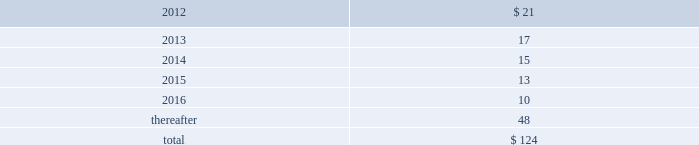The company has also encountered various quality issues on its aircraft carrier construction and overhaul programs and its virginia-class submarine construction program at its newport news location .
These primarily involve matters related to filler metal used in pipe welds identified in 2007 , and issues associated with non-nuclear weld inspection and the installation of weapons handling equipment on certain submarines , and certain purchased material quality issues identified in 2009 .
The company does not believe that resolution of these issues will have a material effect upon its consolidated financial position , results of operations or cash flows .
Environmental matters 2014the estimated cost to complete environmental remediation has been accrued where it is probable that the company will incur such costs in the future to address environmental conditions at currently or formerly owned or leased operating facilities , or at sites where it has been named a potentially responsible party ( 201cprp 201d ) by the environmental protection agency , or similarly designated by another environmental agency , and these costs can be estimated by management .
These accruals do not include any litigation costs related to environmental matters , nor do they include amounts recorded as asset retirement obligations .
To assess the potential impact on the company 2019s consolidated financial statements , management estimates the range of reasonably possible remediation costs that could be incurred by the company , taking into account currently available facts on each site as well as the current state of technology and prior experience in remediating contaminated sites .
These estimates are reviewed periodically and adjusted to reflect changes in facts and technical and legal circumstances .
Management estimates that as of december 31 , 2011 , the probable future costs for environmental remediation is $ 3 million , which is accrued in other current liabilities .
Factors that could result in changes to the company 2019s estimates include : modification of planned remedial actions , increases or decreases in the estimated time required to remediate , changes to the determination of legally responsible parties , discovery of more extensive contamination than anticipated , changes in laws and regulations affecting remediation requirements , and improvements in remediation technology .
Should other prps not pay their allocable share of remediation costs , the company may have to incur costs exceeding those already estimated and accrued .
In addition , there are certain potential remediation sites where the costs of remediation cannot be reasonably estimated .
Although management cannot predict whether new information gained as projects progress will materially affect the estimated liability accrued , management does not believe that future remediation expenditures will have a material effect on the company 2019s consolidated financial position , results of operations or cash flows .
Financial arrangements 2014in the ordinary course of business , hii uses standby letters of credit issued by commercial banks and surety bonds issued by insurance companies principally to support the company 2019s self-insured workers 2019 compensation plans .
At december 31 , 2011 , there were $ 121 million of standby letters of credit issued but undrawn and $ 297 million of surety bonds outstanding related to hii .
U.s .
Government claims 2014from time to time , the u.s .
Government advises the company of claims and penalties concerning certain potential disallowed costs .
When such findings are presented , the company and u.s .
Government representatives engage in discussions to enable hii to evaluate the merits of these claims as well as to assess the amounts being claimed .
The company does not believe that the outcome of any such matters will have a material effect on its consolidated financial position , results of operations or cash flows .
Collective bargaining agreements 2014the company believes that it maintains good relations with its approximately 38000 employees of which approximately 50% ( 50 % ) are covered by a total of 10 collective bargaining agreements .
The company expects to renegotiate renewals of each of its collective bargaining agreements between 2013 and 2015 as they approach expiration .
Collective bargaining agreements generally expire after three to five years and are subject to renegotiation at that time .
It is not expected that the results of these negotiations , either individually or in the aggregate , will have a material effect on the company 2019s consolidated results of operations .
Operating leases 2014rental expense for operating leases was $ 44 million in 2011 , $ 44 million in 2010 , and $ 48 million in 2009 .
These amounts are net of immaterial amounts of sublease rental income .
Minimum rental commitments under long- term non-cancellable operating leases for the next five years and thereafter are : ( $ in millions ) .

What was the average operating leases 2014rental expense for operating leases from 2009 to 2011? 
Computations: (((44 + 44) + 48) / 3)
Answer: 45.33333. The company has also encountered various quality issues on its aircraft carrier construction and overhaul programs and its virginia-class submarine construction program at its newport news location .
These primarily involve matters related to filler metal used in pipe welds identified in 2007 , and issues associated with non-nuclear weld inspection and the installation of weapons handling equipment on certain submarines , and certain purchased material quality issues identified in 2009 .
The company does not believe that resolution of these issues will have a material effect upon its consolidated financial position , results of operations or cash flows .
Environmental matters 2014the estimated cost to complete environmental remediation has been accrued where it is probable that the company will incur such costs in the future to address environmental conditions at currently or formerly owned or leased operating facilities , or at sites where it has been named a potentially responsible party ( 201cprp 201d ) by the environmental protection agency , or similarly designated by another environmental agency , and these costs can be estimated by management .
These accruals do not include any litigation costs related to environmental matters , nor do they include amounts recorded as asset retirement obligations .
To assess the potential impact on the company 2019s consolidated financial statements , management estimates the range of reasonably possible remediation costs that could be incurred by the company , taking into account currently available facts on each site as well as the current state of technology and prior experience in remediating contaminated sites .
These estimates are reviewed periodically and adjusted to reflect changes in facts and technical and legal circumstances .
Management estimates that as of december 31 , 2011 , the probable future costs for environmental remediation is $ 3 million , which is accrued in other current liabilities .
Factors that could result in changes to the company 2019s estimates include : modification of planned remedial actions , increases or decreases in the estimated time required to remediate , changes to the determination of legally responsible parties , discovery of more extensive contamination than anticipated , changes in laws and regulations affecting remediation requirements , and improvements in remediation technology .
Should other prps not pay their allocable share of remediation costs , the company may have to incur costs exceeding those already estimated and accrued .
In addition , there are certain potential remediation sites where the costs of remediation cannot be reasonably estimated .
Although management cannot predict whether new information gained as projects progress will materially affect the estimated liability accrued , management does not believe that future remediation expenditures will have a material effect on the company 2019s consolidated financial position , results of operations or cash flows .
Financial arrangements 2014in the ordinary course of business , hii uses standby letters of credit issued by commercial banks and surety bonds issued by insurance companies principally to support the company 2019s self-insured workers 2019 compensation plans .
At december 31 , 2011 , there were $ 121 million of standby letters of credit issued but undrawn and $ 297 million of surety bonds outstanding related to hii .
U.s .
Government claims 2014from time to time , the u.s .
Government advises the company of claims and penalties concerning certain potential disallowed costs .
When such findings are presented , the company and u.s .
Government representatives engage in discussions to enable hii to evaluate the merits of these claims as well as to assess the amounts being claimed .
The company does not believe that the outcome of any such matters will have a material effect on its consolidated financial position , results of operations or cash flows .
Collective bargaining agreements 2014the company believes that it maintains good relations with its approximately 38000 employees of which approximately 50% ( 50 % ) are covered by a total of 10 collective bargaining agreements .
The company expects to renegotiate renewals of each of its collective bargaining agreements between 2013 and 2015 as they approach expiration .
Collective bargaining agreements generally expire after three to five years and are subject to renegotiation at that time .
It is not expected that the results of these negotiations , either individually or in the aggregate , will have a material effect on the company 2019s consolidated results of operations .
Operating leases 2014rental expense for operating leases was $ 44 million in 2011 , $ 44 million in 2010 , and $ 48 million in 2009 .
These amounts are net of immaterial amounts of sublease rental income .
Minimum rental commitments under long- term non-cancellable operating leases for the next five years and thereafter are : ( $ in millions ) .

What is the percentage change in rent expenses for operating leases in 2010 compare to 2009? 
Computations: ((44 - 48) / 48)
Answer: -0.08333. The company has also encountered various quality issues on its aircraft carrier construction and overhaul programs and its virginia-class submarine construction program at its newport news location .
These primarily involve matters related to filler metal used in pipe welds identified in 2007 , and issues associated with non-nuclear weld inspection and the installation of weapons handling equipment on certain submarines , and certain purchased material quality issues identified in 2009 .
The company does not believe that resolution of these issues will have a material effect upon its consolidated financial position , results of operations or cash flows .
Environmental matters 2014the estimated cost to complete environmental remediation has been accrued where it is probable that the company will incur such costs in the future to address environmental conditions at currently or formerly owned or leased operating facilities , or at sites where it has been named a potentially responsible party ( 201cprp 201d ) by the environmental protection agency , or similarly designated by another environmental agency , and these costs can be estimated by management .
These accruals do not include any litigation costs related to environmental matters , nor do they include amounts recorded as asset retirement obligations .
To assess the potential impact on the company 2019s consolidated financial statements , management estimates the range of reasonably possible remediation costs that could be incurred by the company , taking into account currently available facts on each site as well as the current state of technology and prior experience in remediating contaminated sites .
These estimates are reviewed periodically and adjusted to reflect changes in facts and technical and legal circumstances .
Management estimates that as of december 31 , 2011 , the probable future costs for environmental remediation is $ 3 million , which is accrued in other current liabilities .
Factors that could result in changes to the company 2019s estimates include : modification of planned remedial actions , increases or decreases in the estimated time required to remediate , changes to the determination of legally responsible parties , discovery of more extensive contamination than anticipated , changes in laws and regulations affecting remediation requirements , and improvements in remediation technology .
Should other prps not pay their allocable share of remediation costs , the company may have to incur costs exceeding those already estimated and accrued .
In addition , there are certain potential remediation sites where the costs of remediation cannot be reasonably estimated .
Although management cannot predict whether new information gained as projects progress will materially affect the estimated liability accrued , management does not believe that future remediation expenditures will have a material effect on the company 2019s consolidated financial position , results of operations or cash flows .
Financial arrangements 2014in the ordinary course of business , hii uses standby letters of credit issued by commercial banks and surety bonds issued by insurance companies principally to support the company 2019s self-insured workers 2019 compensation plans .
At december 31 , 2011 , there were $ 121 million of standby letters of credit issued but undrawn and $ 297 million of surety bonds outstanding related to hii .
U.s .
Government claims 2014from time to time , the u.s .
Government advises the company of claims and penalties concerning certain potential disallowed costs .
When such findings are presented , the company and u.s .
Government representatives engage in discussions to enable hii to evaluate the merits of these claims as well as to assess the amounts being claimed .
The company does not believe that the outcome of any such matters will have a material effect on its consolidated financial position , results of operations or cash flows .
Collective bargaining agreements 2014the company believes that it maintains good relations with its approximately 38000 employees of which approximately 50% ( 50 % ) are covered by a total of 10 collective bargaining agreements .
The company expects to renegotiate renewals of each of its collective bargaining agreements between 2013 and 2015 as they approach expiration .
Collective bargaining agreements generally expire after three to five years and are subject to renegotiation at that time .
It is not expected that the results of these negotiations , either individually or in the aggregate , will have a material effect on the company 2019s consolidated results of operations .
Operating leases 2014rental expense for operating leases was $ 44 million in 2011 , $ 44 million in 2010 , and $ 48 million in 2009 .
These amounts are net of immaterial amounts of sublease rental income .
Minimum rental commitments under long- term non-cancellable operating leases for the next five years and thereafter are : ( $ in millions ) .

What portion of the total rental commitments for non-cancellable operating lease is due in the next 12 months? 
Computations: (21 / 124)
Answer: 0.16935. 